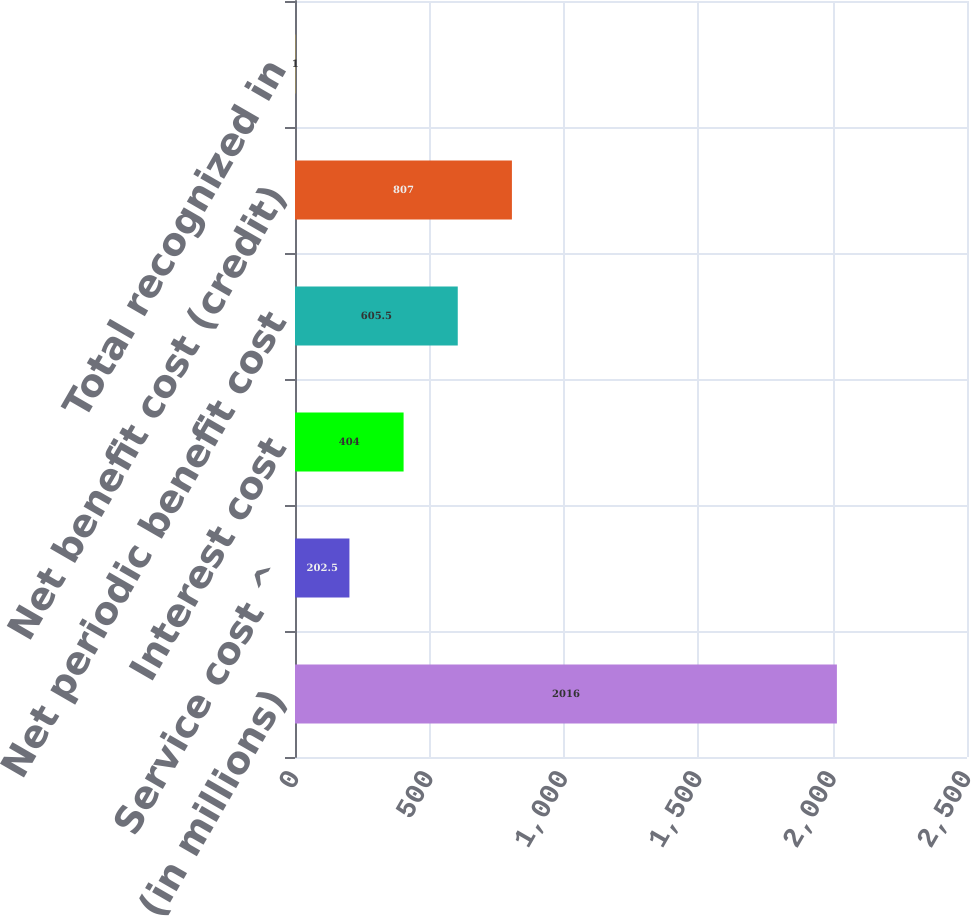<chart> <loc_0><loc_0><loc_500><loc_500><bar_chart><fcel>(in millions)<fcel>Service cost ^<fcel>Interest cost<fcel>Net periodic benefit cost<fcel>Net benefit cost (credit)<fcel>Total recognized in<nl><fcel>2016<fcel>202.5<fcel>404<fcel>605.5<fcel>807<fcel>1<nl></chart> 